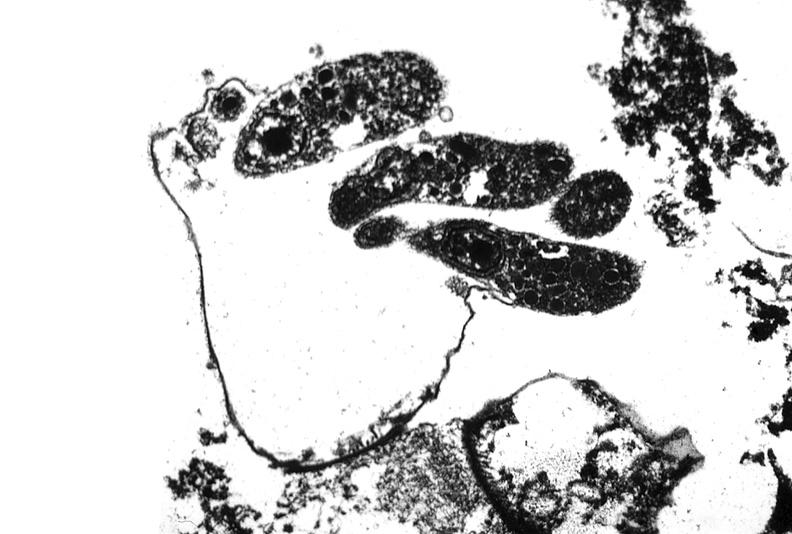s gastrointestinal present?
Answer the question using a single word or phrase. Yes 